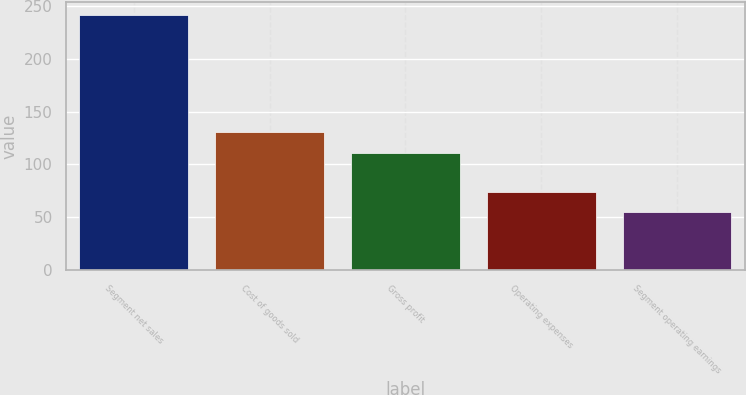<chart> <loc_0><loc_0><loc_500><loc_500><bar_chart><fcel>Segment net sales<fcel>Cost of goods sold<fcel>Gross profit<fcel>Operating expenses<fcel>Segment operating earnings<nl><fcel>241.6<fcel>130.4<fcel>111.2<fcel>74.02<fcel>55.4<nl></chart> 